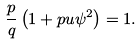<formula> <loc_0><loc_0><loc_500><loc_500>\frac { p } { q } \left ( 1 + p u \psi ^ { 2 } \right ) = 1 .</formula> 